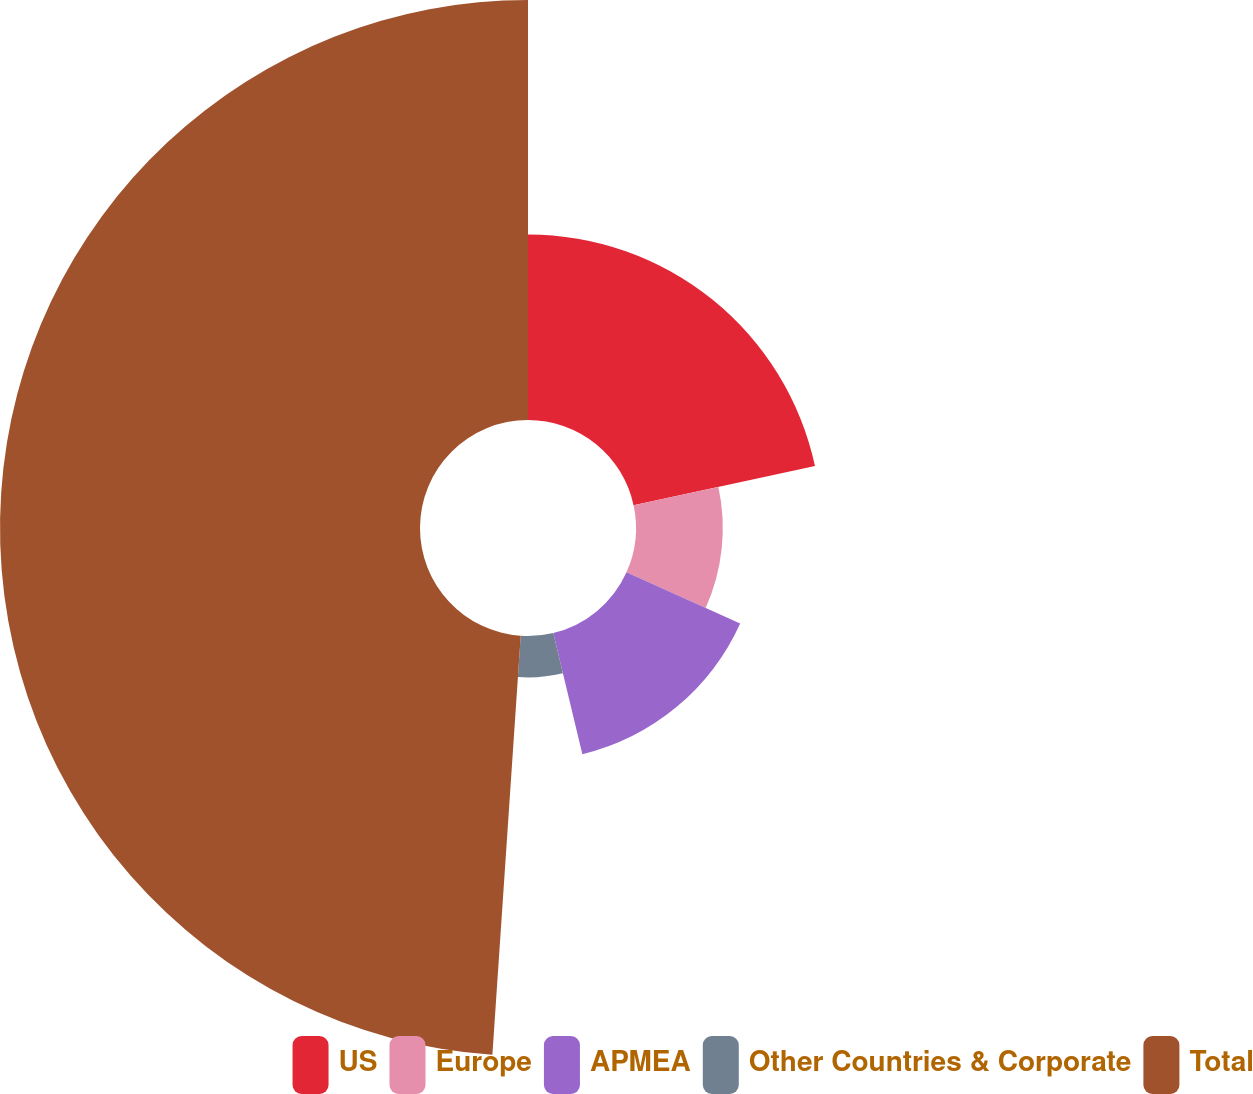Convert chart. <chart><loc_0><loc_0><loc_500><loc_500><pie_chart><fcel>US<fcel>Europe<fcel>APMEA<fcel>Other Countries & Corporate<fcel>Total<nl><fcel>21.62%<fcel>10.11%<fcel>14.52%<fcel>4.83%<fcel>48.93%<nl></chart> 